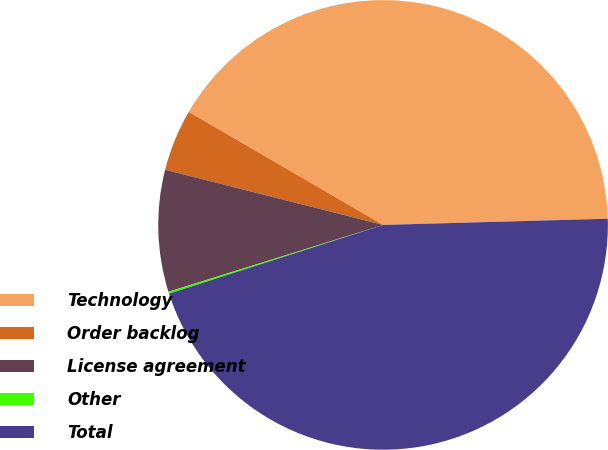<chart> <loc_0><loc_0><loc_500><loc_500><pie_chart><fcel>Technology<fcel>Order backlog<fcel>License agreement<fcel>Other<fcel>Total<nl><fcel>41.18%<fcel>4.44%<fcel>8.75%<fcel>0.14%<fcel>45.49%<nl></chart> 